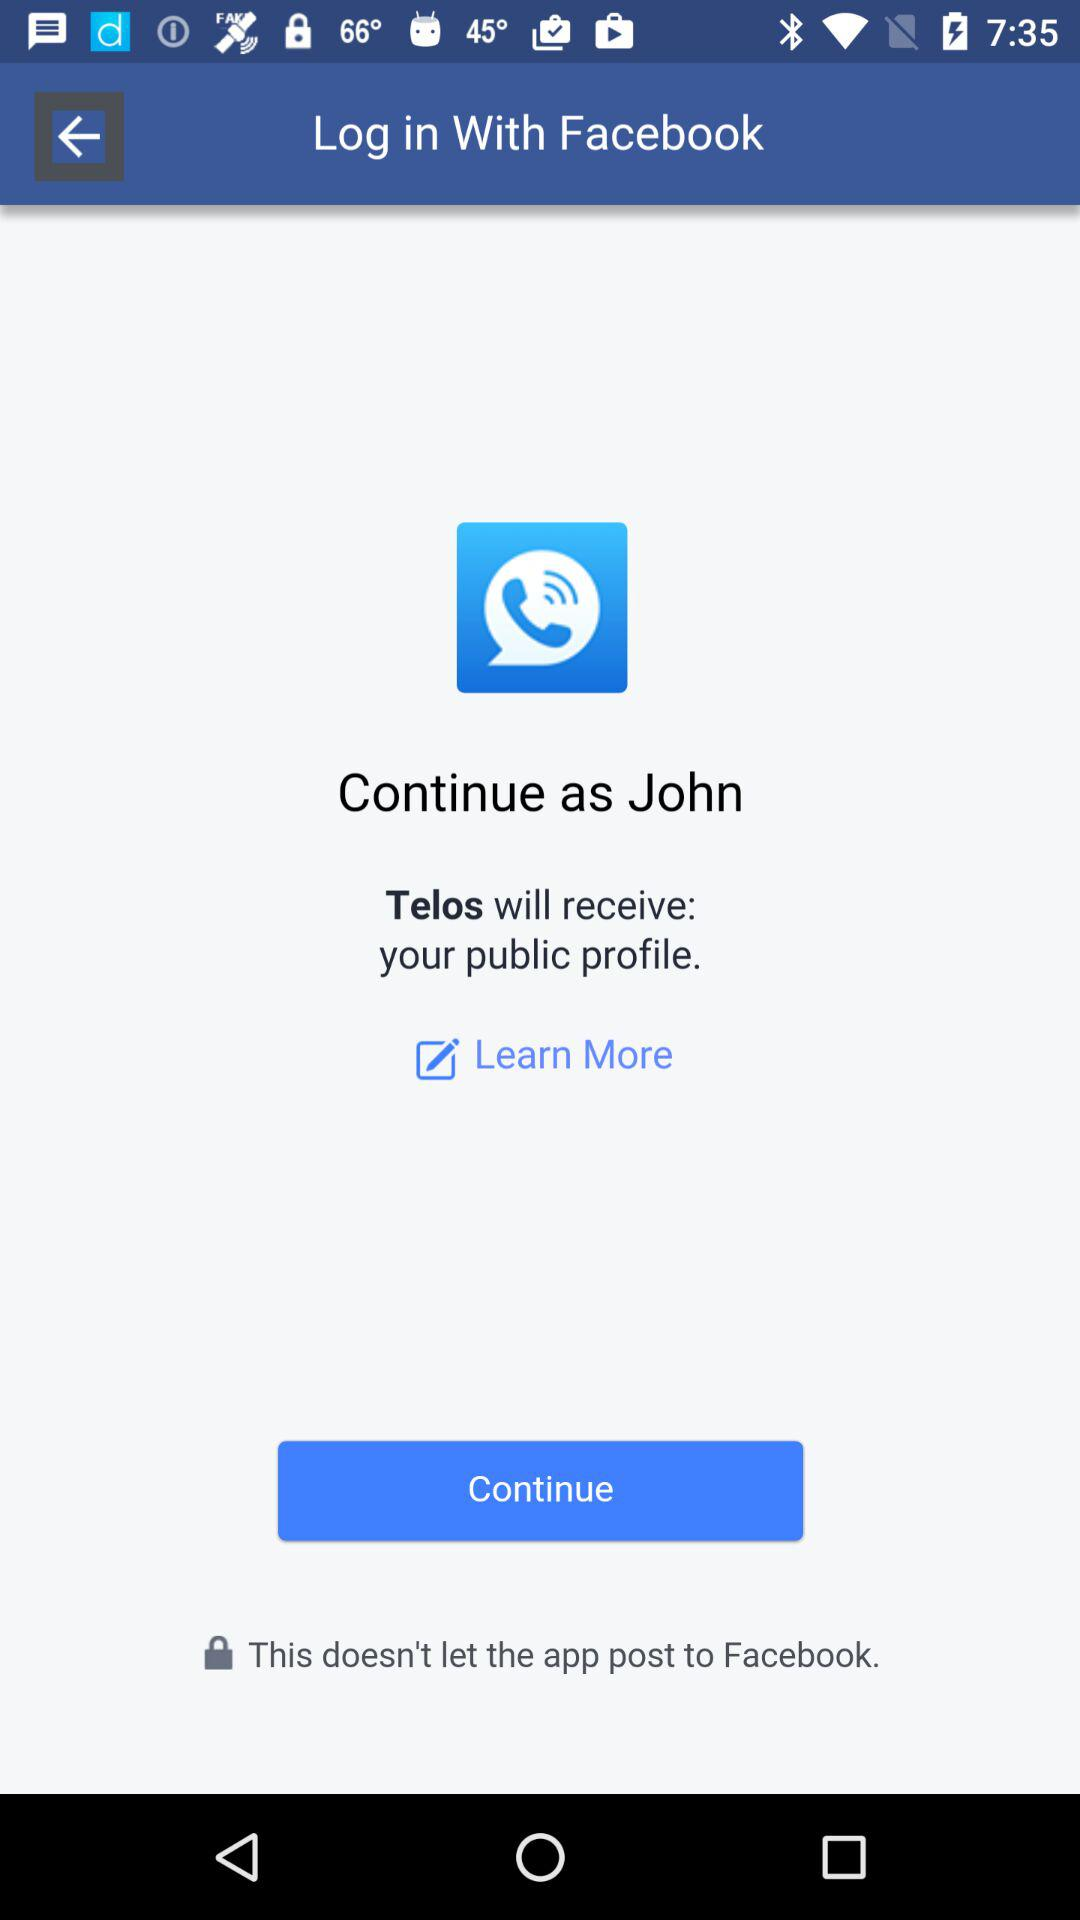What is the login name? The login name is John. 